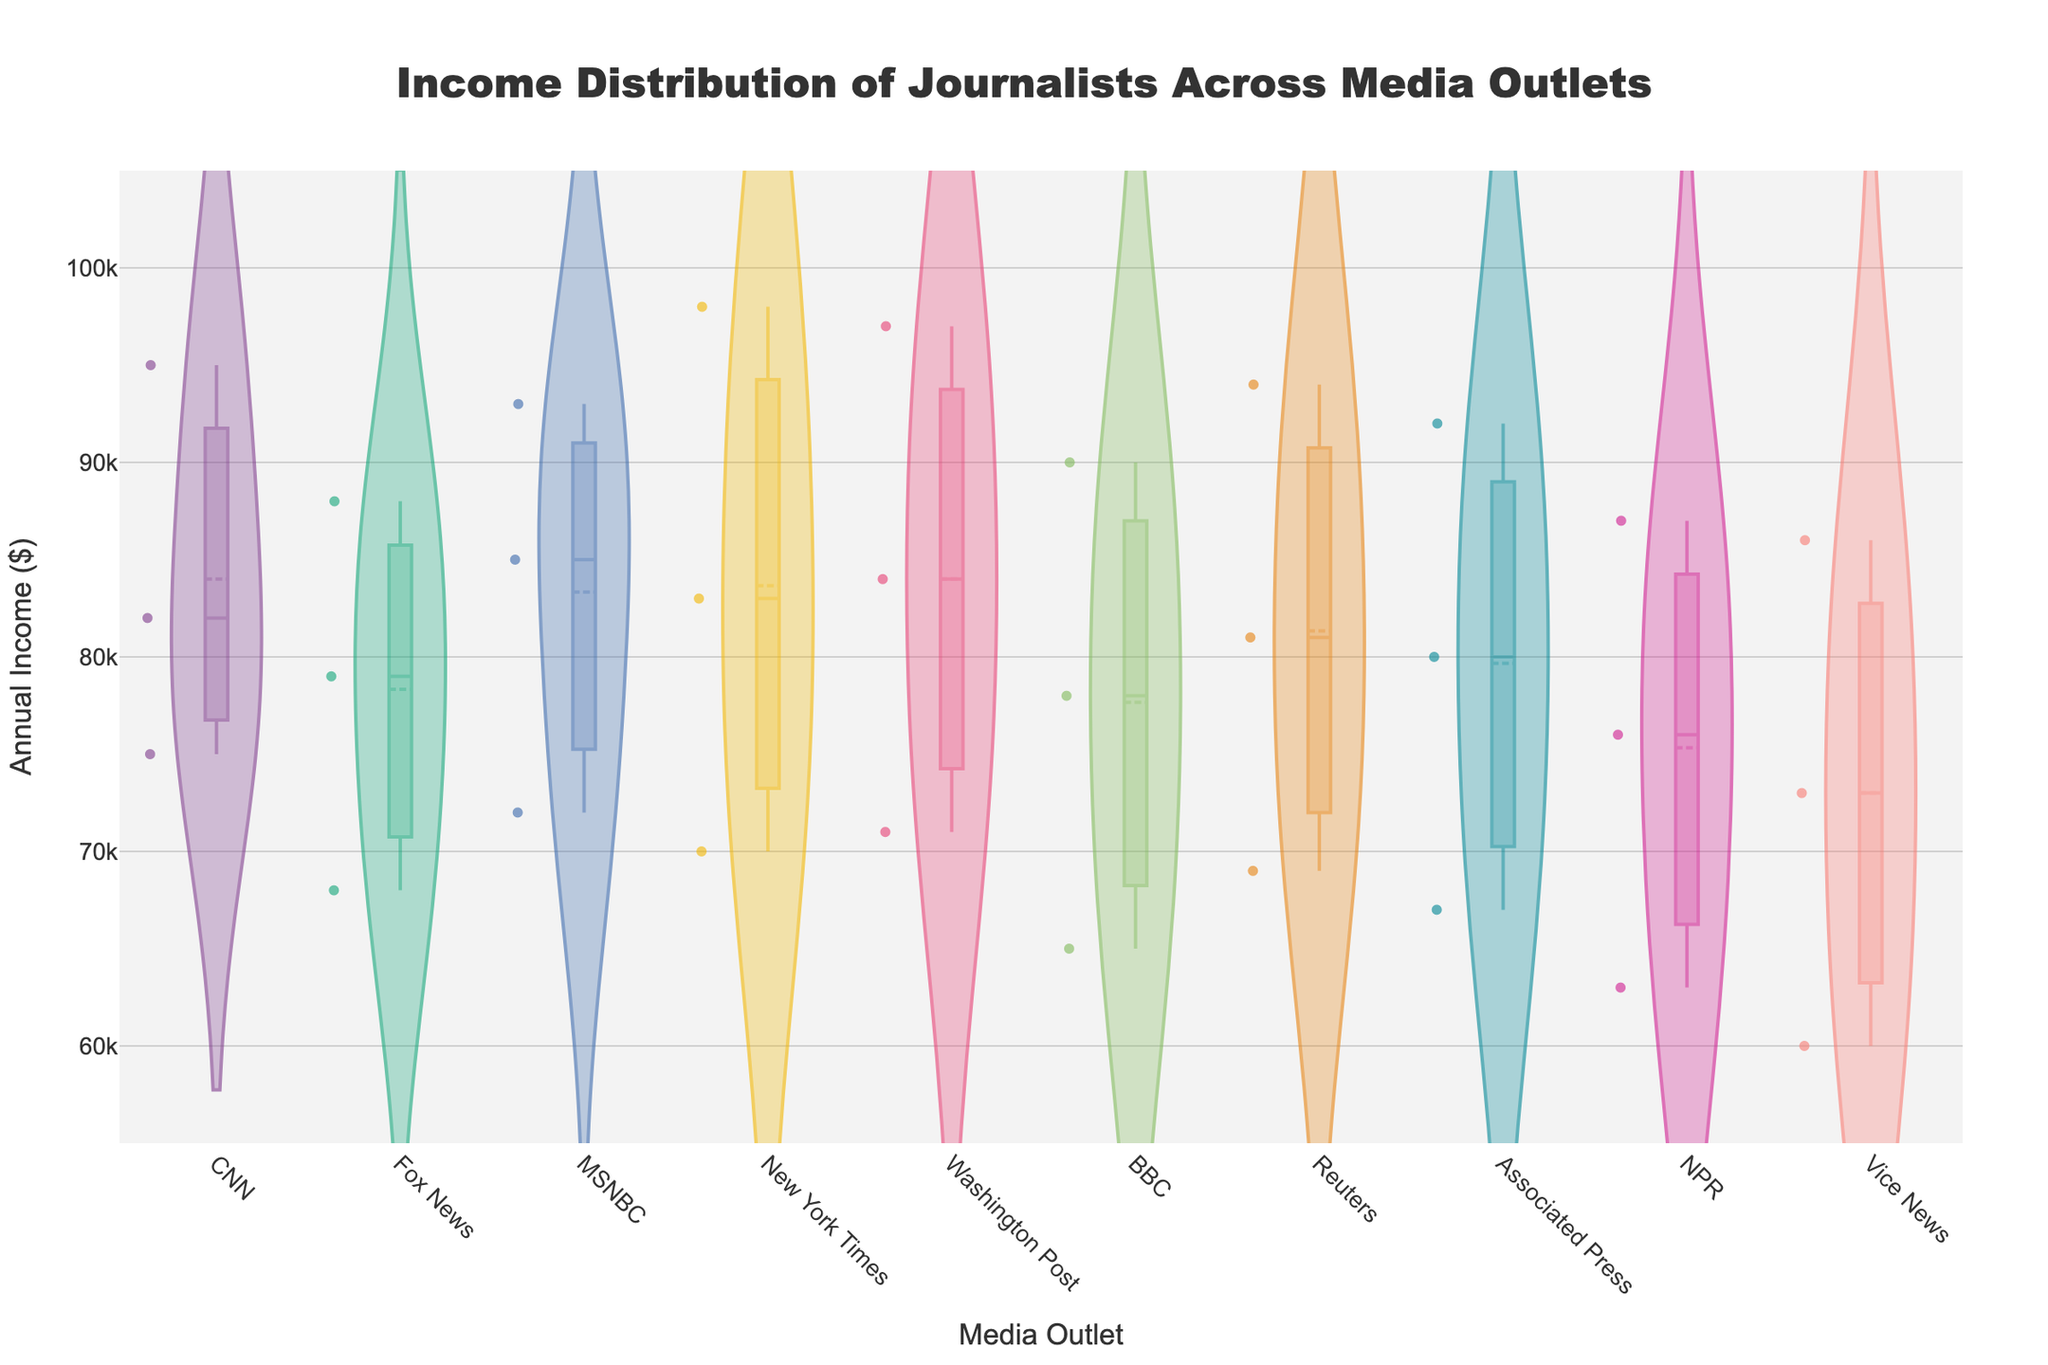what is the title of the figure? The title is located at the top center of the figure. Reading the visual information, it states "Income Distribution of Journalists Across Media Outlets".
Answer: Income Distribution of Journalists Across Media Outlets how does the income range vary among different media outlets? Observing the y-axis, which represents the annual income in dollars, and noting the scatter points within the violin plots, we can see that incomes typically vary between $60,000 to $100,000 across different media outlets.
Answer: $60,000 to $100,000 which media outlet shows the highest median annual income? The median annual income is represented by the white dot line within each violin plot. Observing the positioning of these lines, the New York Times and Washington Post have the highest median incomes.
Answer: New York Times and Washington Post how many data points are plotted for each media outlet? Each scatter point within the violin plot represents an individual data point corresponding to a journalist's annual income from various media outlets. Every outlet has only 3 data points representing three values.
Answer: 3 which media outlet has the widest spread in annual income? The spread of income is represented by the width of the violin plot. The New York Times has the widest spread, indicating the highest income variability among its journalists.
Answer: New York Times on average, does BBC have higher or lower median income compared to NPR? Observing and comparing the white dot lines within each of the two violin plots, BBC's median income appears to be higher than NPR's median income.
Answer: Higher comparing CNN and Fox News, which outlet has higher mean annual income? The mean line within the violin plots indicates the average income. Observing the mean lines for both CNN and Fox News, CNN has a higher mean annual income.
Answer: CNN which outlets show more varied income distribution, Vice News or Associated Press? By comparing the width and spread of the violin plots, Vice News shows more variation in income distribution compared to Associated Press.
Answer: Vice News is there any overlap in income distribution between any two media outlets? By carefully examining the violin plots side-by-side, we observe overlaps among the majority of media outlets, indicating similar ranges of income distribution.
Answer: Yes what visual element indicates the presence of some extreme values or outliers in incomes? The scatter points outside the main body of the violin plot indicate outliers or extreme income values within each media outlet's distribution.
Answer: Scatter points 